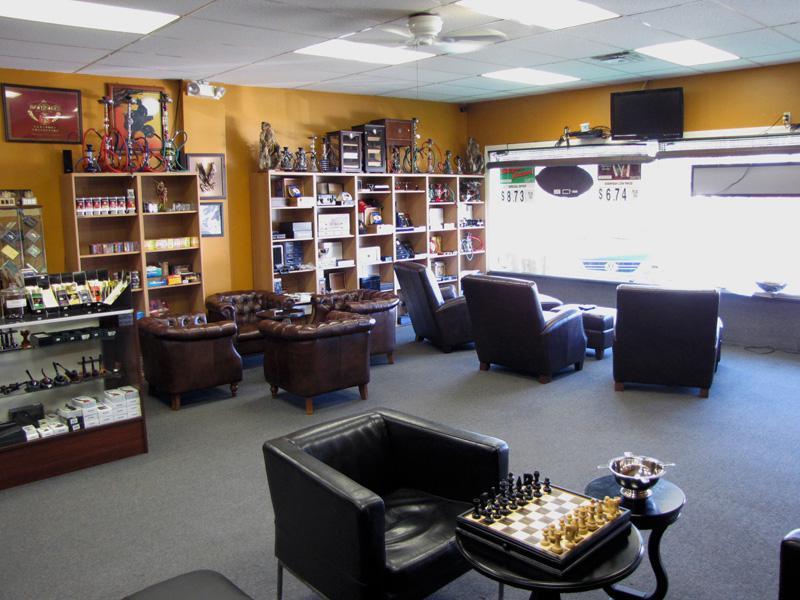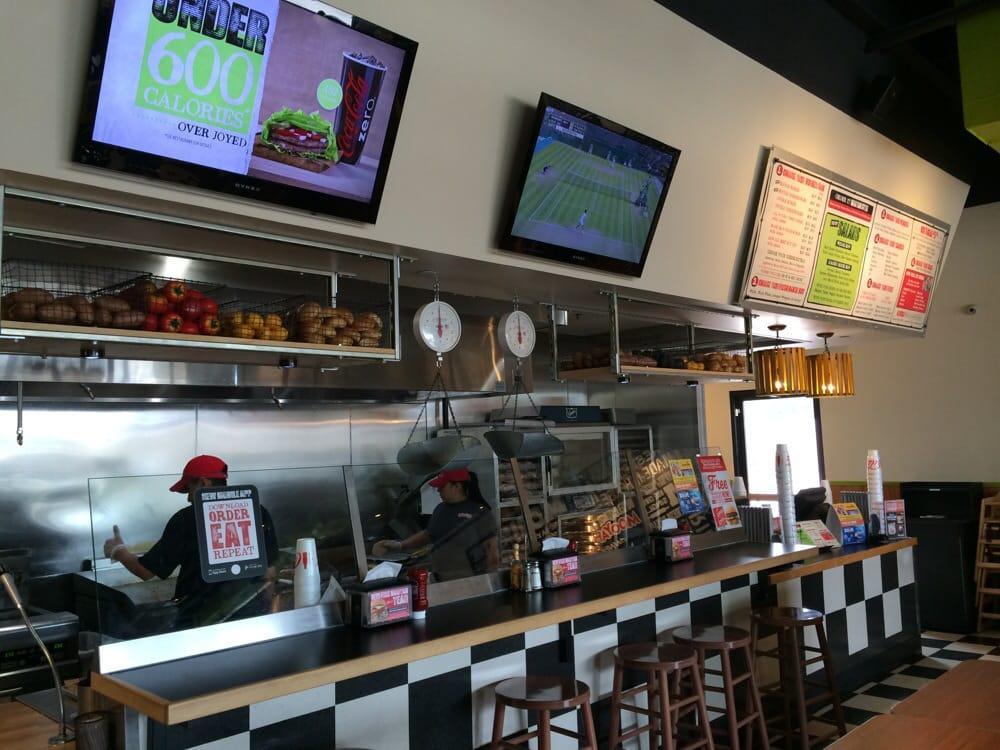The first image is the image on the left, the second image is the image on the right. Analyze the images presented: Is the assertion "There are spotlights hanging from the ceiling in one of the images." valid? Answer yes or no. No. 